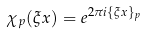Convert formula to latex. <formula><loc_0><loc_0><loc_500><loc_500>\chi _ { p } ( \xi x ) = e ^ { 2 \pi i \{ \xi x \} _ { p } }</formula> 